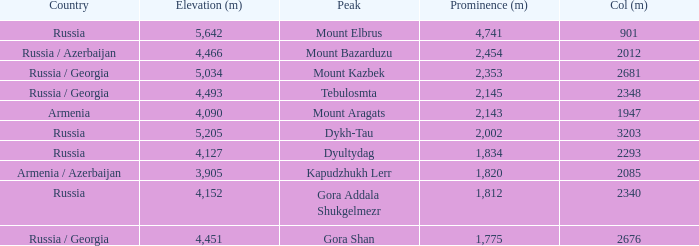What is the Col (m) of Peak Mount Aragats with an Elevation (m) larger than 3,905 and Prominence smaller than 2,143? None. 